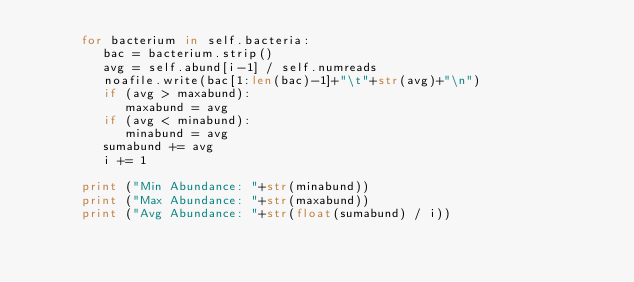<code> <loc_0><loc_0><loc_500><loc_500><_Python_>      for bacterium in self.bacteria:
         bac = bacterium.strip()
         avg = self.abund[i-1] / self.numreads
         noafile.write(bac[1:len(bac)-1]+"\t"+str(avg)+"\n")
         if (avg > maxabund):
            maxabund = avg
         if (avg < minabund):
            minabund = avg 
         sumabund += avg
         i += 1

      print ("Min Abundance: "+str(minabund))
      print ("Max Abundance: "+str(maxabund))
      print ("Avg Abundance: "+str(float(sumabund) / i))
</code> 